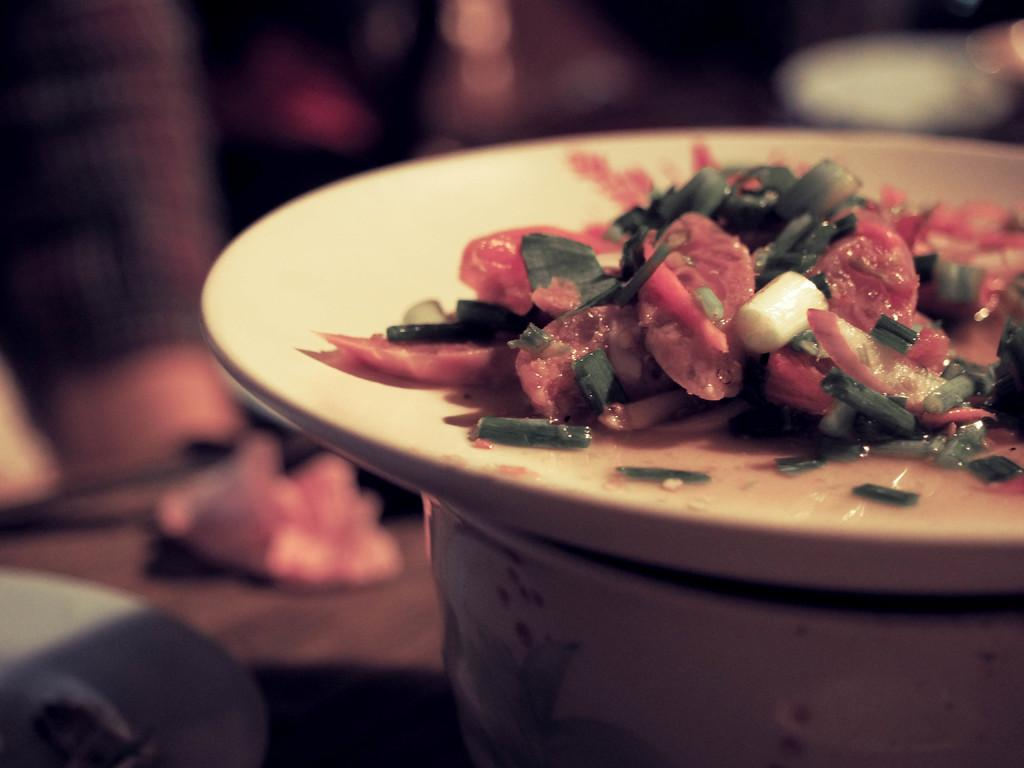What is on the plate in the image? There is a food item on the plate in the image. Can you describe the background of the image? The background of the image is blurred. How is the plate positioned in the image? The plate is on another vessel in the image. What stage of development is the bomb in the image? There is no bomb present in the image. How does the stomach of the person in the image look? There is no person or stomach visible in the image. 